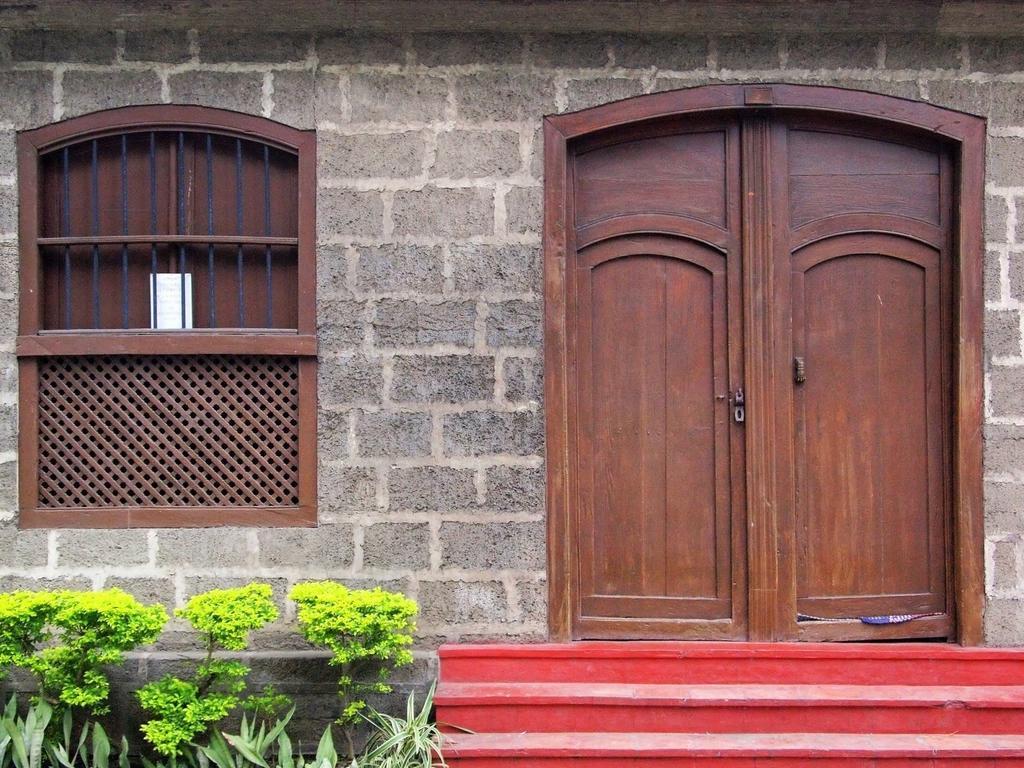In one or two sentences, can you explain what this image depicts? In this picture I can see a wall with doors and a window, there are plants and stairs. 